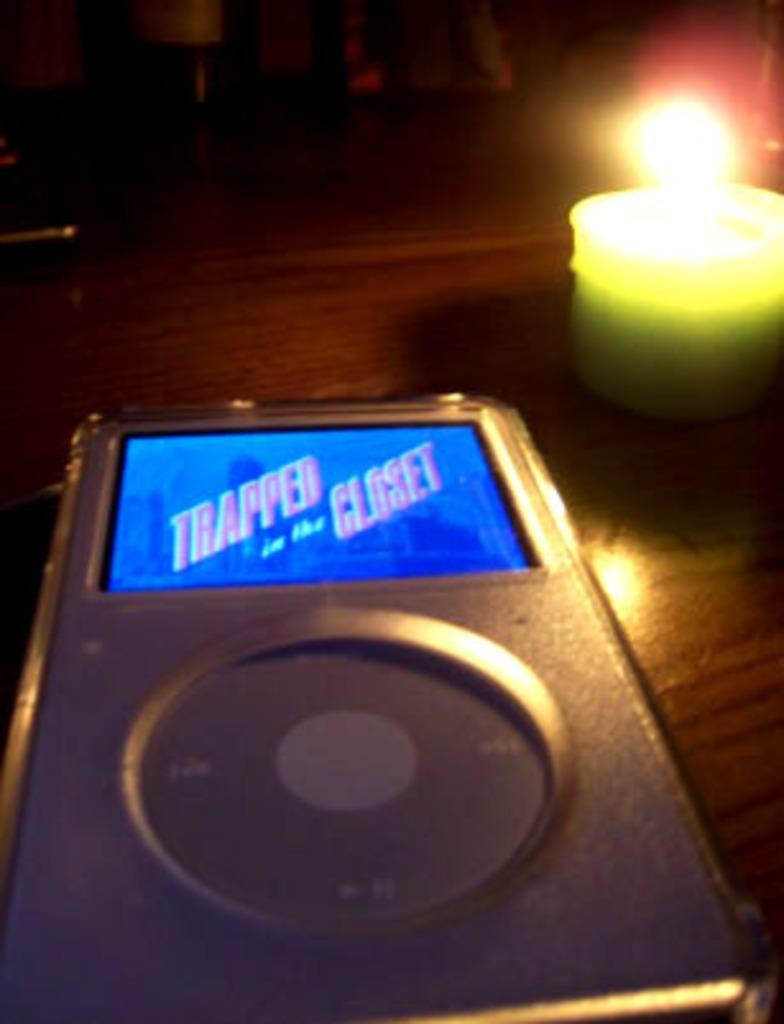In one or two sentences, can you explain what this image depicts? Here in this picture we can see an Ipod and a candle, which is lightened up present on the table over there. 